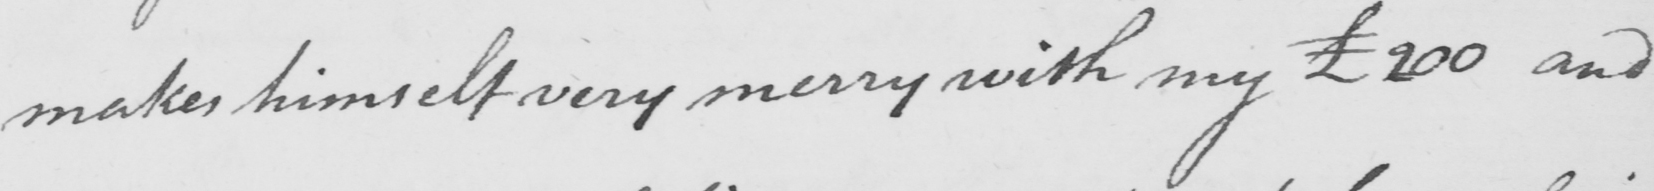Please transcribe the handwritten text in this image. makes himself very merry with my £200 and 